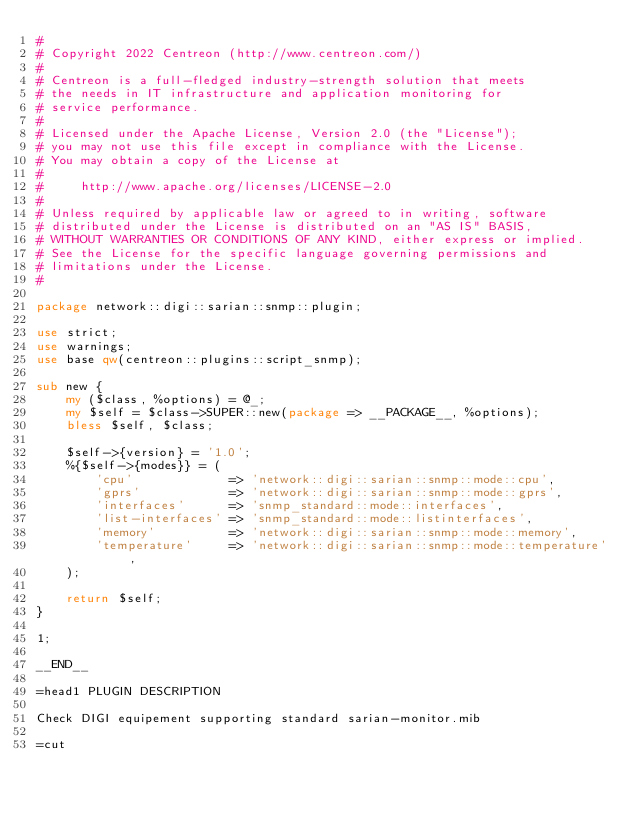<code> <loc_0><loc_0><loc_500><loc_500><_Perl_>#
# Copyright 2022 Centreon (http://www.centreon.com/)
#
# Centreon is a full-fledged industry-strength solution that meets
# the needs in IT infrastructure and application monitoring for
# service performance.
#
# Licensed under the Apache License, Version 2.0 (the "License");
# you may not use this file except in compliance with the License.
# You may obtain a copy of the License at
#
#     http://www.apache.org/licenses/LICENSE-2.0
#
# Unless required by applicable law or agreed to in writing, software
# distributed under the License is distributed on an "AS IS" BASIS,
# WITHOUT WARRANTIES OR CONDITIONS OF ANY KIND, either express or implied.
# See the License for the specific language governing permissions and
# limitations under the License.
#

package network::digi::sarian::snmp::plugin;

use strict;
use warnings;
use base qw(centreon::plugins::script_snmp);

sub new {
    my ($class, %options) = @_;
    my $self = $class->SUPER::new(package => __PACKAGE__, %options);
    bless $self, $class;

    $self->{version} = '1.0';
    %{$self->{modes}} = (
        'cpu'             => 'network::digi::sarian::snmp::mode::cpu',
        'gprs'            => 'network::digi::sarian::snmp::mode::gprs',
        'interfaces'      => 'snmp_standard::mode::interfaces',
        'list-interfaces' => 'snmp_standard::mode::listinterfaces',
        'memory'          => 'network::digi::sarian::snmp::mode::memory',
        'temperature'     => 'network::digi::sarian::snmp::mode::temperature',
    );

    return $self;
}

1;

__END__

=head1 PLUGIN DESCRIPTION

Check DIGI equipement supporting standard sarian-monitor.mib

=cut
</code> 